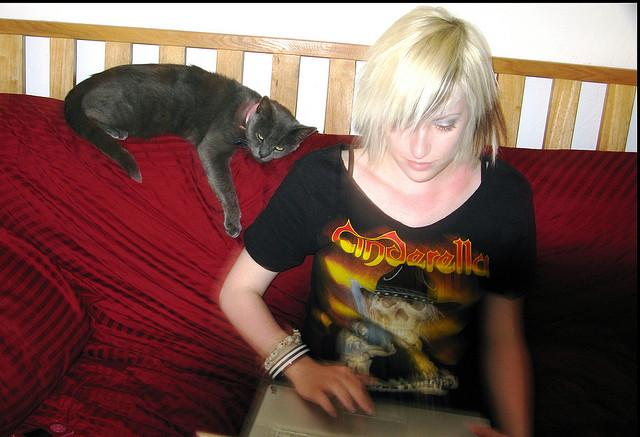What type of furniture is the girl sitting on?

Choices:
A) futon
B) recliner
C) chaise
D) sectional futon 